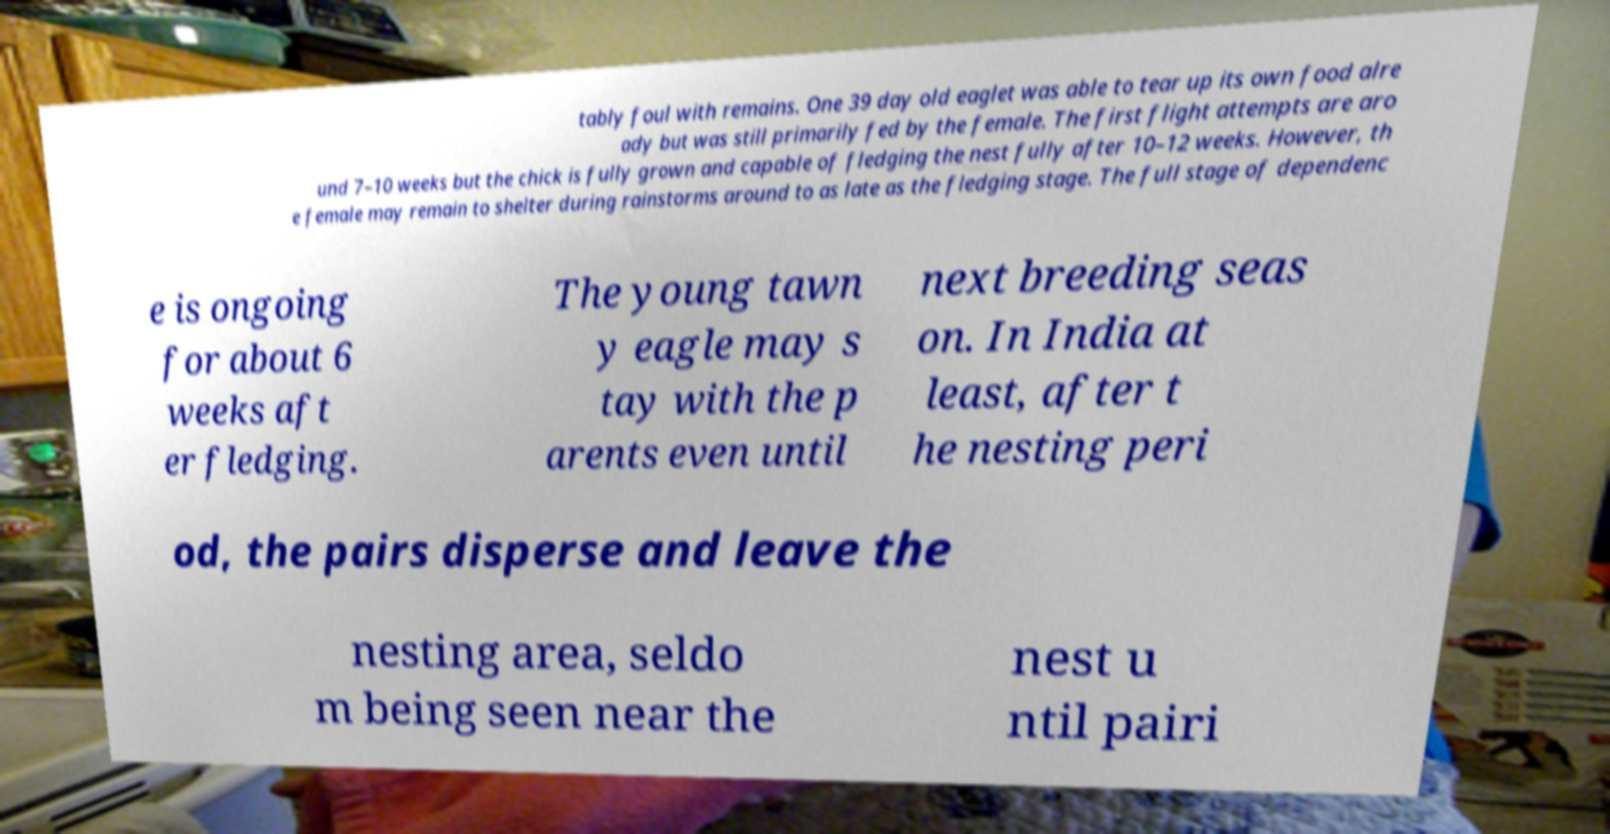Please identify and transcribe the text found in this image. tably foul with remains. One 39 day old eaglet was able to tear up its own food alre ady but was still primarily fed by the female. The first flight attempts are aro und 7–10 weeks but the chick is fully grown and capable of fledging the nest fully after 10–12 weeks. However, th e female may remain to shelter during rainstorms around to as late as the fledging stage. The full stage of dependenc e is ongoing for about 6 weeks aft er fledging. The young tawn y eagle may s tay with the p arents even until next breeding seas on. In India at least, after t he nesting peri od, the pairs disperse and leave the nesting area, seldo m being seen near the nest u ntil pairi 